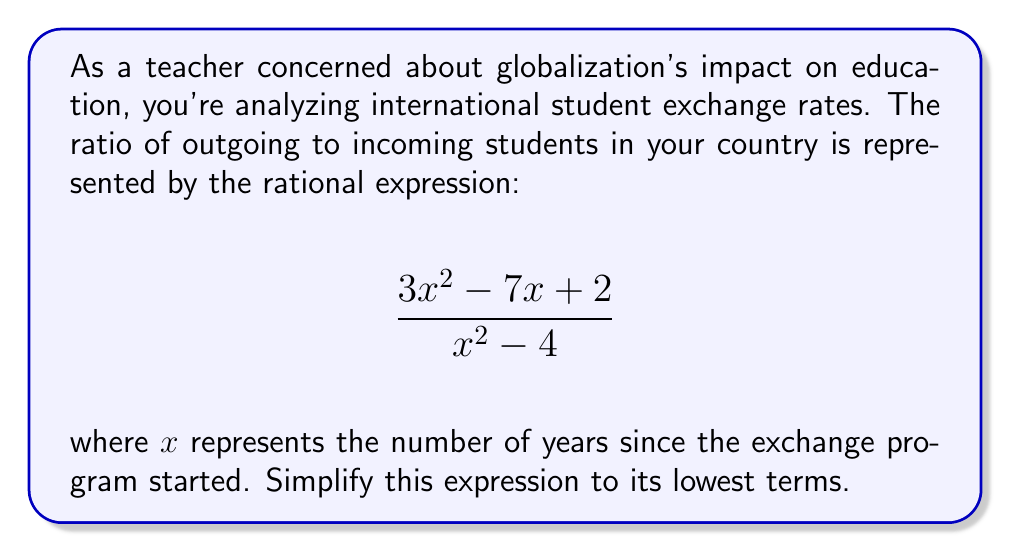Teach me how to tackle this problem. To simplify this rational expression, we'll follow these steps:

1) First, factor the numerator and denominator:

   Numerator: $3x^2 - 7x + 2$
   This is a quadratic expression. We can factor it using the ac-method:
   $3x^2 - 7x + 2 = (3x - 1)(x - 2)$

   Denominator: $x^2 - 4$
   This is a difference of squares:
   $x^2 - 4 = (x+2)(x-2)$

2) Now our expression looks like this:

   $$\frac{(3x - 1)(x - 2)}{(x+2)(x-2)}$$

3) We can cancel the common factor $(x-2)$ from the numerator and denominator:

   $$\frac{3x - 1}{x+2}$$

4) This expression cannot be simplified further as there are no common factors between the numerator and denominator.
Answer: $$\frac{3x - 1}{x+2}$$ 